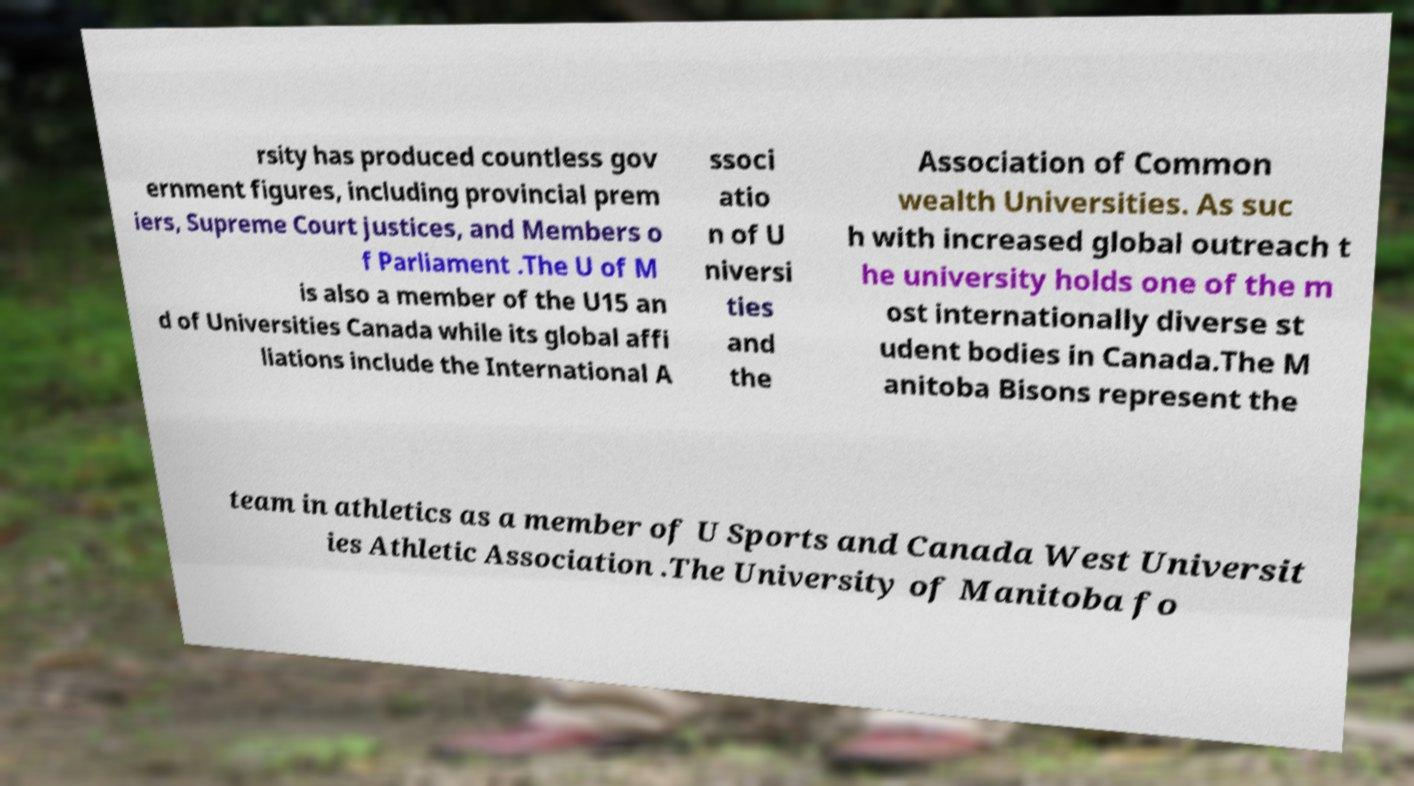Could you assist in decoding the text presented in this image and type it out clearly? rsity has produced countless gov ernment figures, including provincial prem iers, Supreme Court justices, and Members o f Parliament .The U of M is also a member of the U15 an d of Universities Canada while its global affi liations include the International A ssoci atio n of U niversi ties and the Association of Common wealth Universities. As suc h with increased global outreach t he university holds one of the m ost internationally diverse st udent bodies in Canada.The M anitoba Bisons represent the team in athletics as a member of U Sports and Canada West Universit ies Athletic Association .The University of Manitoba fo 